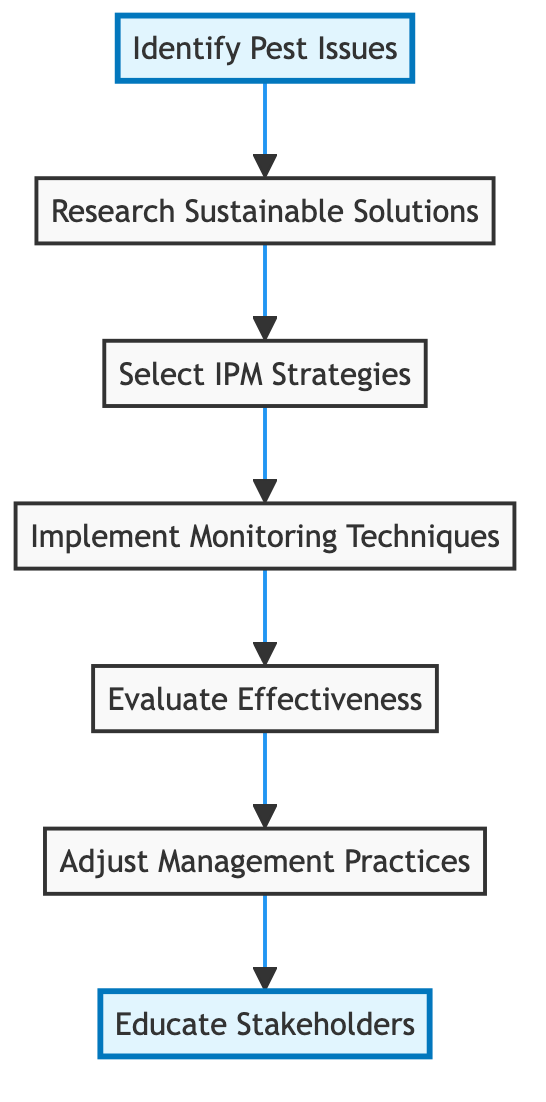What is the first step in the evaluation process? The diagram indicates that the first step in the evaluation process is to "Identify Pest Issues." This is the initial action that starts the flow of the chart.
Answer: Identify Pest Issues How many total steps are outlined in the diagram? By counting the nodes in the diagram, it can be seen that there are a total of seven steps, from identifying pest issues to educating stakeholders.
Answer: 7 What comes after "Research Sustainable Solutions"? The diagram shows that after "Research Sustainable Solutions," the next step is "Select Integrated Pest Management (IPM) Strategies." This follows logically in the sequence of actions.
Answer: Select Integrated Pest Management (IPM) Strategies Which step involves assessing the performance of pest management strategies? According to the flow chart, the step that involves assessing the performance of pest management strategies is "Evaluate Effectiveness of Strategies." This step analyzes how well the strategies have worked.
Answer: Evaluate Effectiveness of Strategies What is the last action taken in the diagram? The final action in the diagram is "Educate Stakeholders." This indicates the importance of knowledge-sharing and training in sustainable pest management.
Answer: Educate Stakeholders What is the relationship between "Implement Monitoring Techniques" and "Evaluate Effectiveness of Strategies"? "Implement Monitoring Techniques" is a prerequisite for "Evaluate Effectiveness of Strategies." The monitoring is necessary to gather data that informs the evaluation of effectiveness.
Answer: Prerequisite If there are adjustments needed, which step follows that action? If adjustments are needed in the management practices, the next step that follows is "Educate Stakeholders," as improved practices need to be communicated to the relevant parties.
Answer: Educate Stakeholders What type of management strategies are selected in this diagram? The diagram specifies that the strategies selected are "Integrated Pest Management (IPM) Strategies," which combine various methods for pest control tailored to specific situations.
Answer: Integrated Pest Management (IPM) Strategies Explain how "Adjust Management Practices" connects to prior steps. "Adjust Management Practices" relies on the results from "Evaluate Effectiveness of Strategies." This requires previous data on pest population dynamics and crop yield, which were collected from earlier steps like monitoring and implementing solutions.
Answer: Connected to evaluation results 